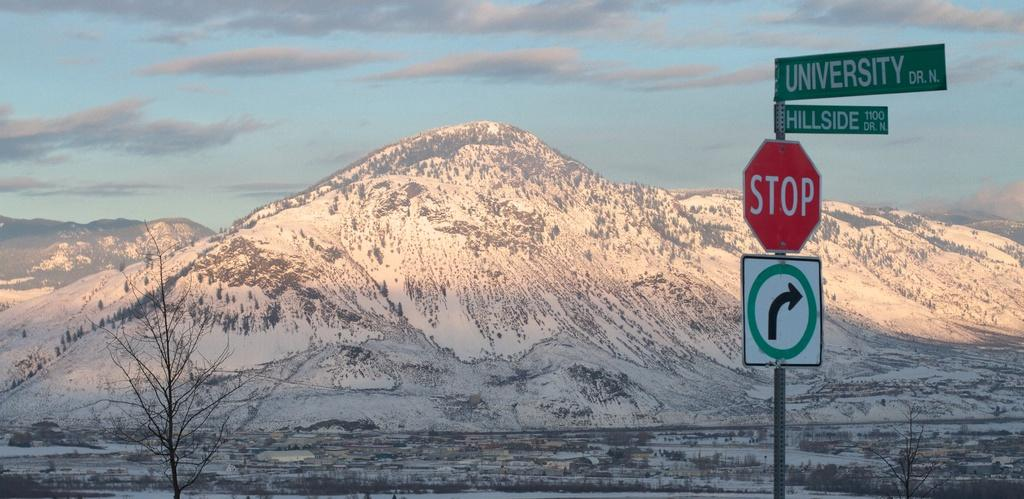<image>
Share a concise interpretation of the image provided. snow on the mountain and bare trees along with stop sign 